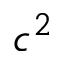Convert formula to latex. <formula><loc_0><loc_0><loc_500><loc_500>c ^ { 2 }</formula> 